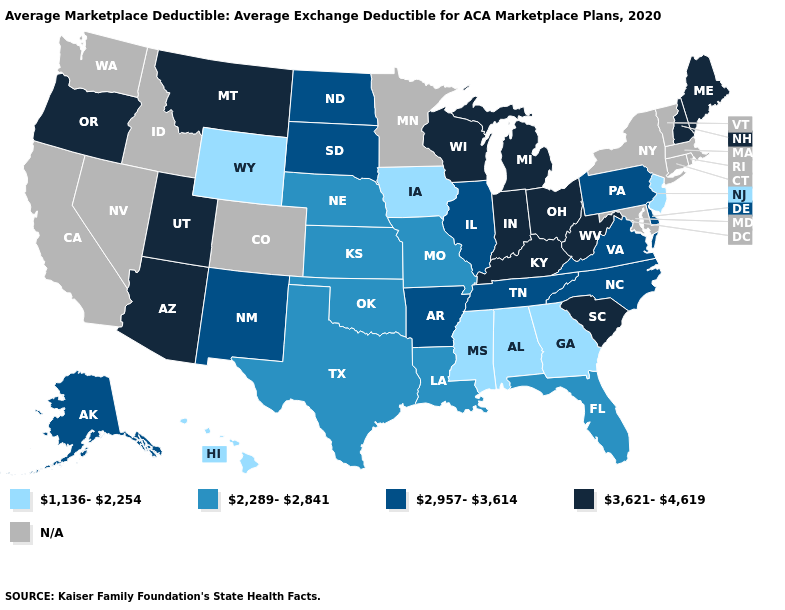What is the value of Arizona?
Be succinct. 3,621-4,619. What is the value of Vermont?
Write a very short answer. N/A. What is the highest value in states that border New Mexico?
Answer briefly. 3,621-4,619. What is the value of West Virginia?
Write a very short answer. 3,621-4,619. What is the lowest value in the USA?
Answer briefly. 1,136-2,254. Which states hav the highest value in the MidWest?
Write a very short answer. Indiana, Michigan, Ohio, Wisconsin. How many symbols are there in the legend?
Answer briefly. 5. Name the states that have a value in the range 2,289-2,841?
Concise answer only. Florida, Kansas, Louisiana, Missouri, Nebraska, Oklahoma, Texas. Is the legend a continuous bar?
Write a very short answer. No. What is the value of Washington?
Give a very brief answer. N/A. Does North Carolina have the highest value in the South?
Be succinct. No. What is the value of North Carolina?
Quick response, please. 2,957-3,614. 